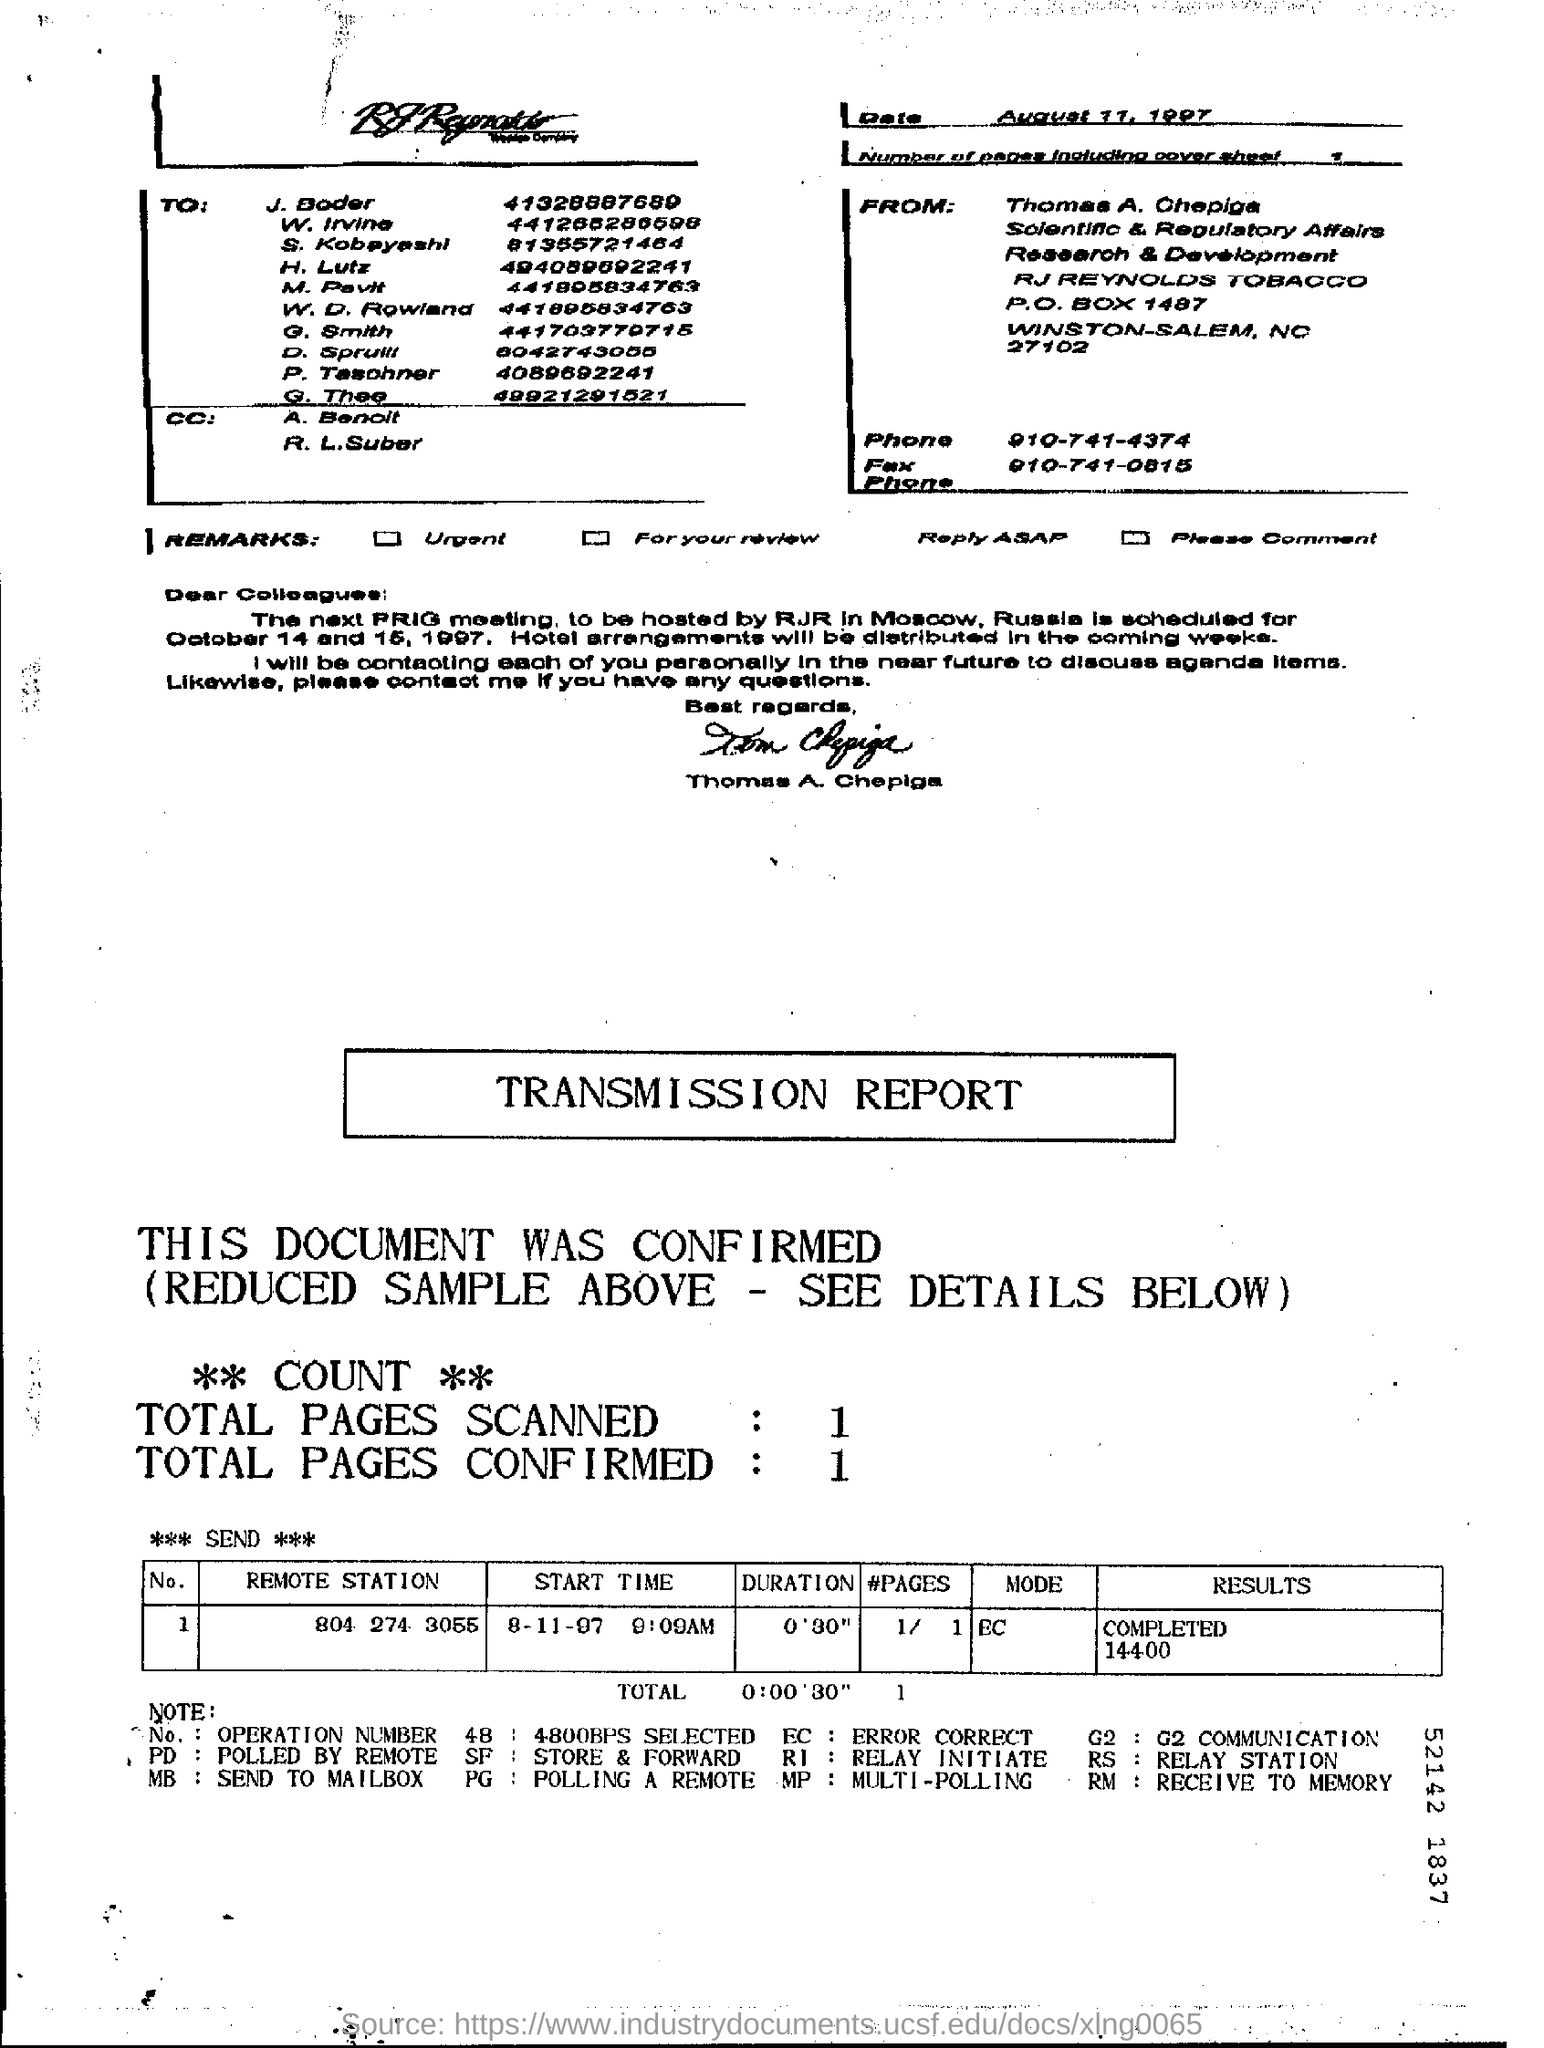Give some essential details in this illustration. What is the mode for the remote station number 804 274 3055? The total number of pages confirmed is 1.. The date on the document is August 11, 1997. The duration for the Remote Station 804 274 3055 is 30 seconds. The total number of pages scanned is 1.. 